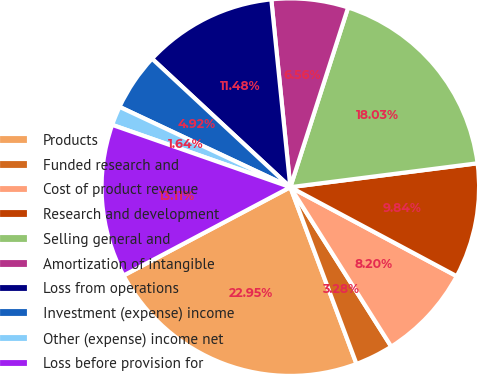<chart> <loc_0><loc_0><loc_500><loc_500><pie_chart><fcel>Products<fcel>Funded research and<fcel>Cost of product revenue<fcel>Research and development<fcel>Selling general and<fcel>Amortization of intangible<fcel>Loss from operations<fcel>Investment (expense) income<fcel>Other (expense) income net<fcel>Loss before provision for<nl><fcel>22.95%<fcel>3.28%<fcel>8.2%<fcel>9.84%<fcel>18.03%<fcel>6.56%<fcel>11.48%<fcel>4.92%<fcel>1.64%<fcel>13.11%<nl></chart> 